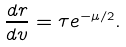<formula> <loc_0><loc_0><loc_500><loc_500>\frac { d r } { d v } = \tau e ^ { - \mu / 2 } .</formula> 